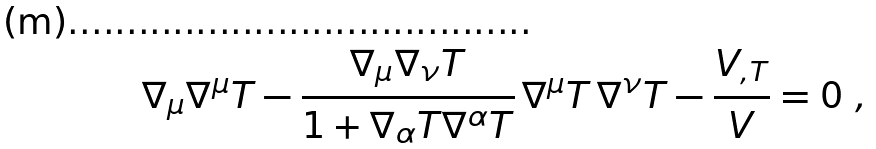<formula> <loc_0><loc_0><loc_500><loc_500>\nabla _ { \mu } \nabla ^ { \mu } T - \frac { \nabla _ { \mu } \nabla _ { \nu } T } { 1 + \nabla _ { \alpha } T \nabla ^ { \alpha } T } \, \nabla ^ { \mu } T \, \nabla ^ { \nu } T - \frac { V _ { , T } } { V } = 0 \ ,</formula> 